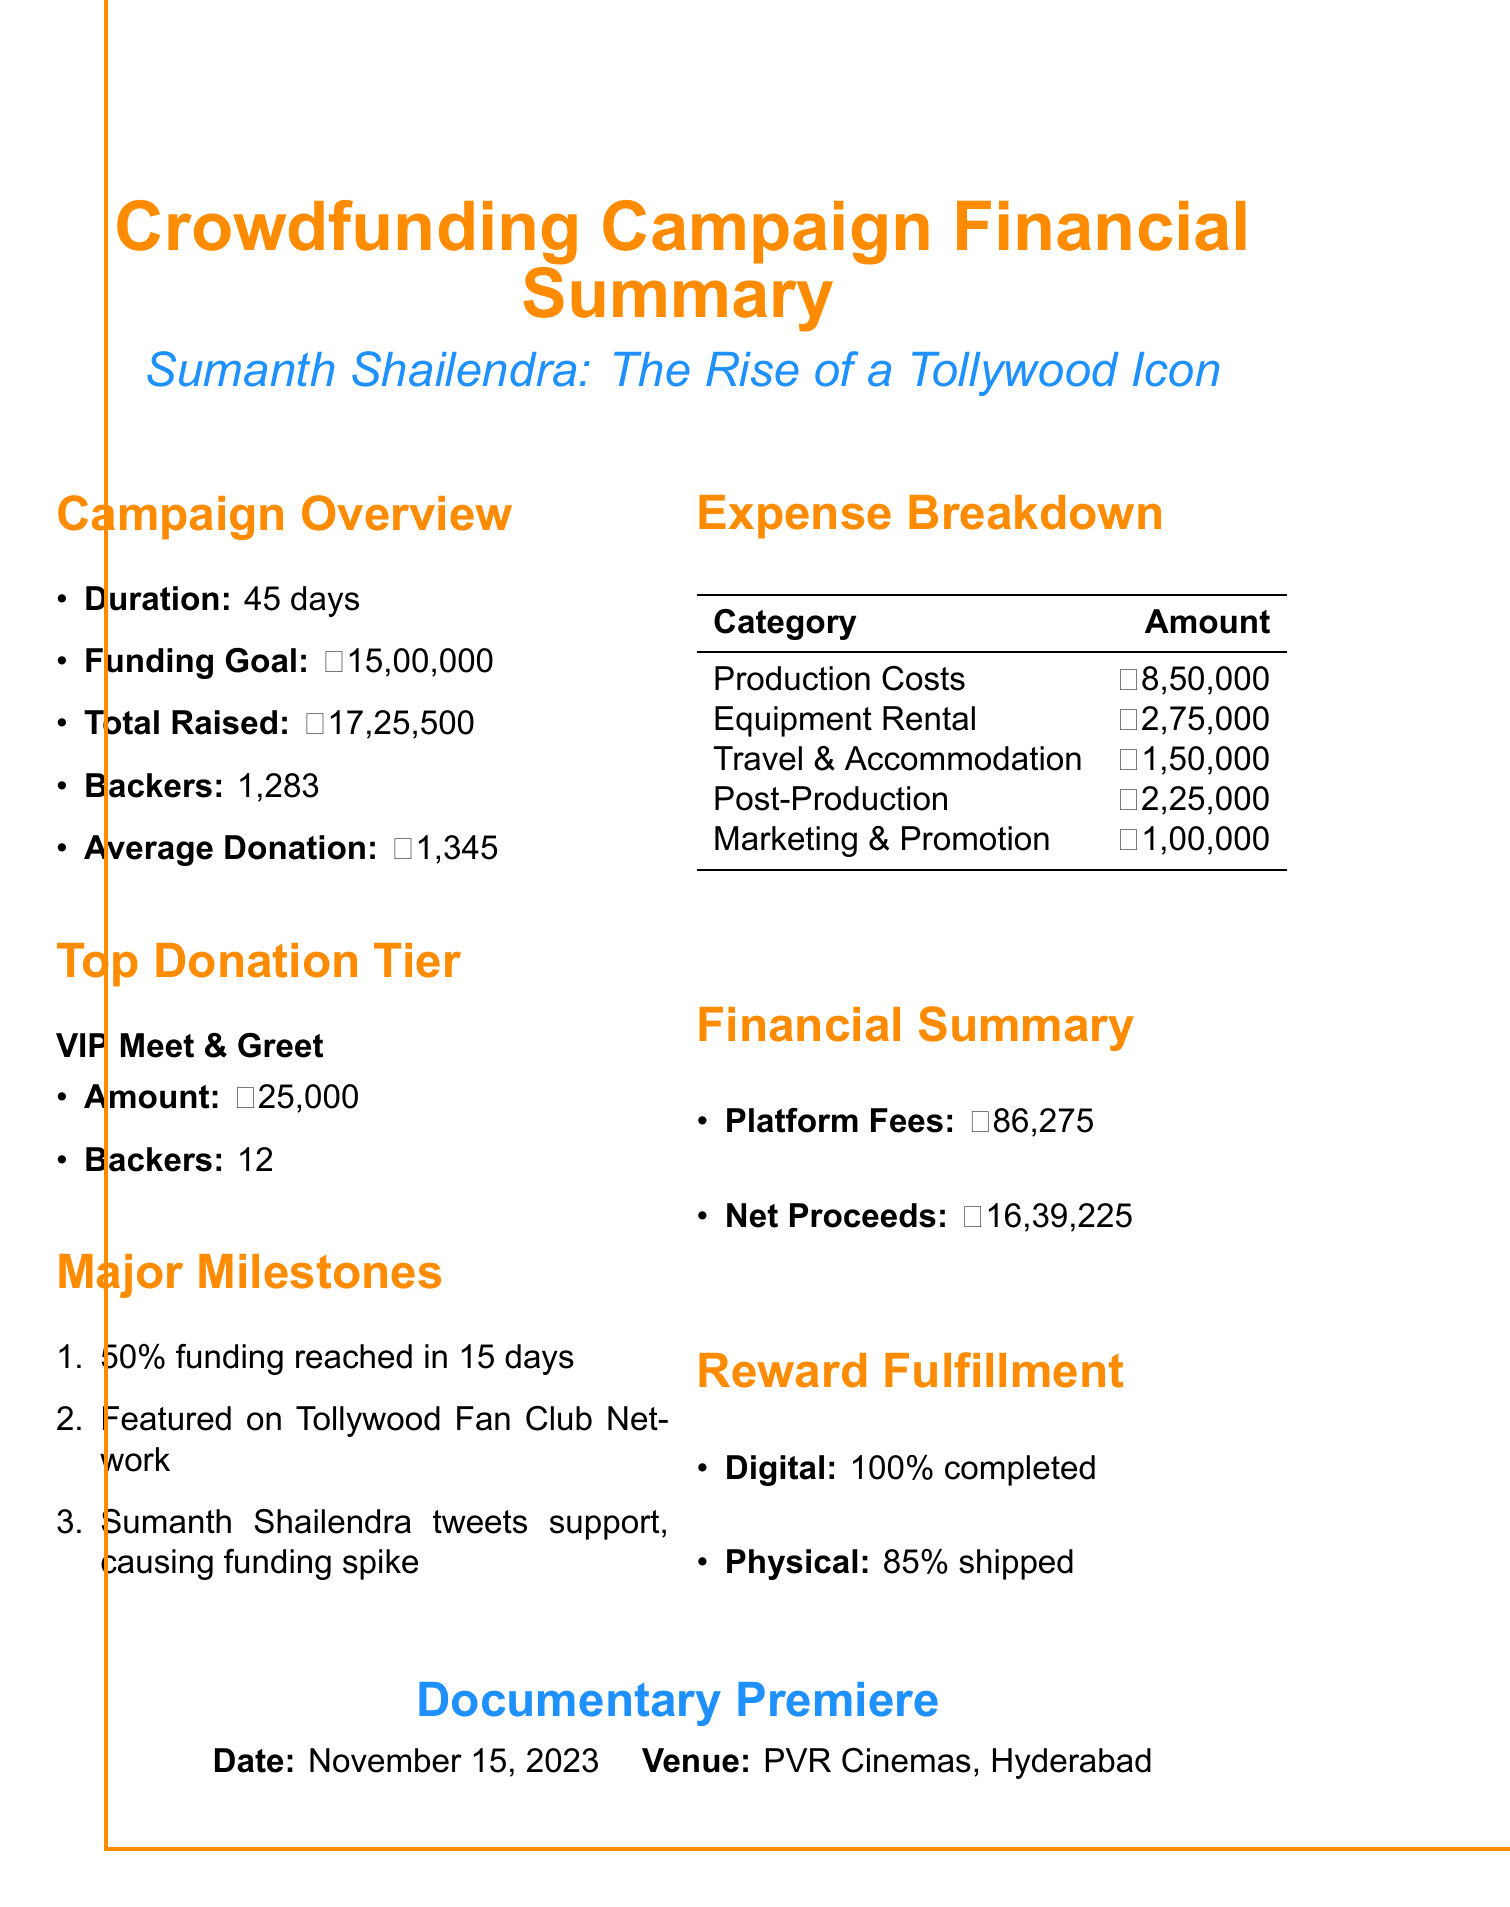what is the campaign title? The campaign title is explicitly stated in the document as the focus of the crowdfunding effort.
Answer: Sumanth Shailendra: The Rise of a Tollywood Icon how many backers contributed to the campaign? The document lists the total number of backers who participated in the campaign, which reflects community support.
Answer: 1283 what was the funding goal for the campaign? The funding goal is specified in the document, providing a target for the fundraising effort.
Answer: ₹15,00,000 what percentage of funding was reached in the first 15 days? The document mentions a major milestone regarding funding achievement within a specific timeframe.
Answer: 50% how much was spent on production costs? The expense breakdown section indicates specific amounts allocated for various budget categories, including production.
Answer: ₹8,50,000 what is the premiere date of the documentary? The documentary premiere date is provided in a distinct section at the end of the document, highlighting the release schedule.
Answer: November 15, 2023 how much is the top donation tier? The document clearly states the amount for the top donation tier, showcasing premium support options for backers.
Answer: ₹25,000 what is the status of digital reward fulfillment? The reward fulfillment status indicates the completion rate for different types of rewards offered to backers.
Answer: 100% completed how much were the platform fees? The financial summary section states the amount deducted as platform fees from the total funds raised, impacting net proceeds.
Answer: ₹86,275 